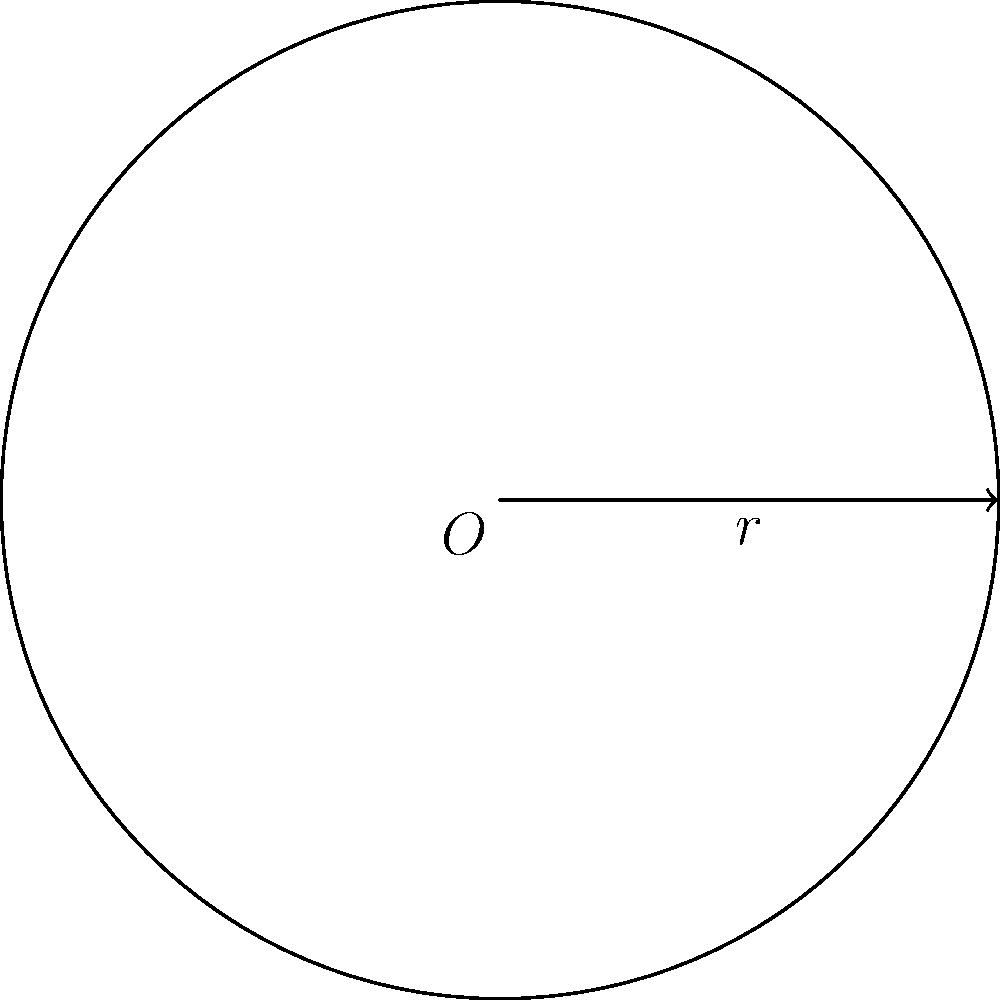Your company is designing a new circular logo for a global marketing campaign. The radius of the logo is 15 meters. Calculate the area of the logo design to determine the amount of material needed for large-scale displays. Round your answer to the nearest whole number. To calculate the area of a circular logo, we use the formula for the area of a circle:

$$A = \pi r^2$$

Where:
$A$ = Area of the circle
$\pi$ = Pi (approximately 3.14159)
$r$ = Radius of the circle

Given:
Radius ($r$) = 15 meters

Step 1: Substitute the values into the formula
$$A = \pi \times 15^2$$

Step 2: Calculate the square of the radius
$$A = \pi \times 225$$

Step 3: Multiply by π
$$A = 706.86 \text{ m}^2$$

Step 4: Round to the nearest whole number
$$A \approx 707 \text{ m}^2$$

Therefore, the area of the logo design is approximately 707 square meters.
Answer: 707 m² 